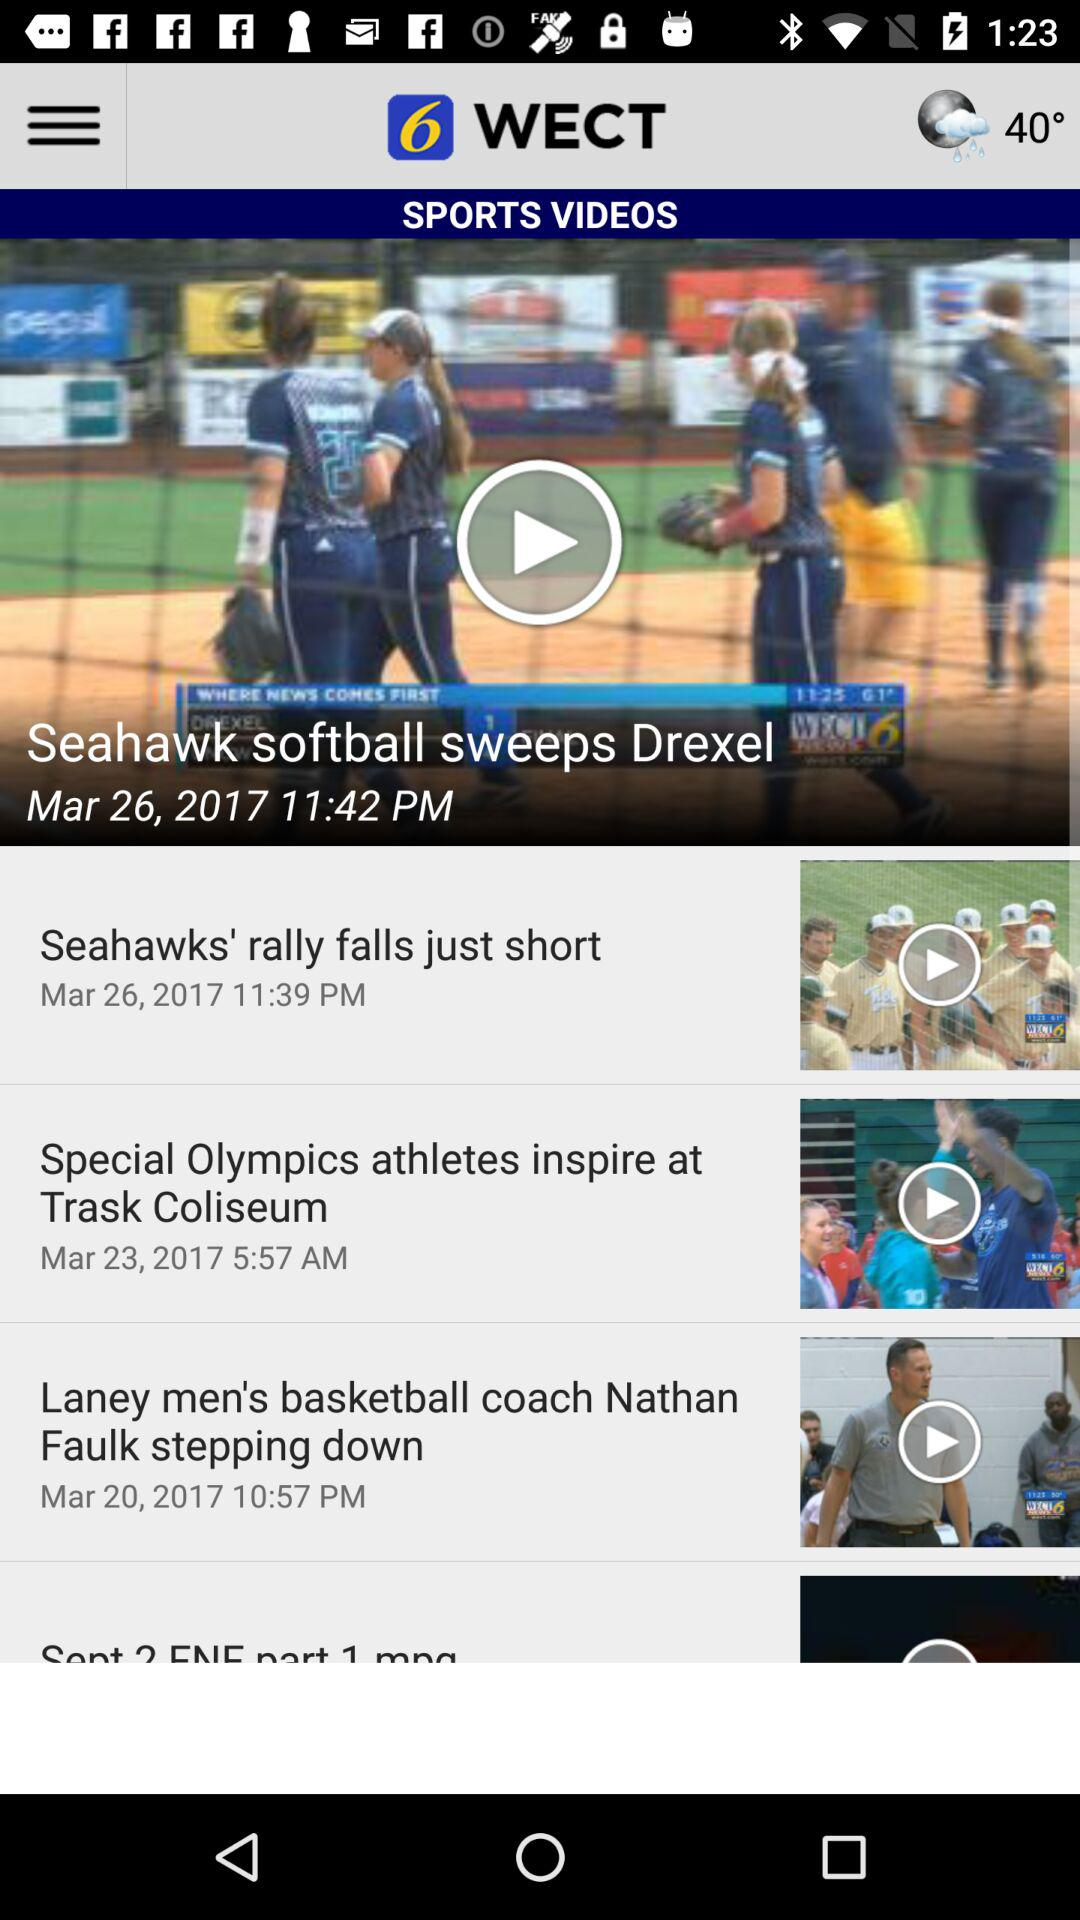How is the weather? The weather is sprinkly. 